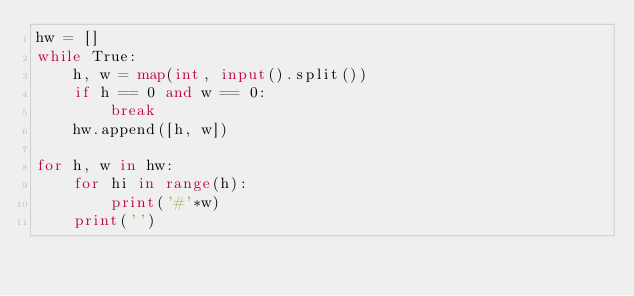<code> <loc_0><loc_0><loc_500><loc_500><_Python_>hw = []
while True:
    h, w = map(int, input().split())
    if h == 0 and w == 0:
        break
    hw.append([h, w])

for h, w in hw:
    for hi in range(h):
        print('#'*w)
    print('')

</code> 